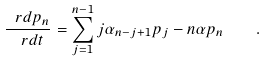<formula> <loc_0><loc_0><loc_500><loc_500>\frac { \ r d p _ { n } } { \ r d t } = \sum _ { j = 1 } ^ { n - 1 } j \alpha _ { n - j + 1 } p _ { j } - n \alpha p _ { n } \quad .</formula> 